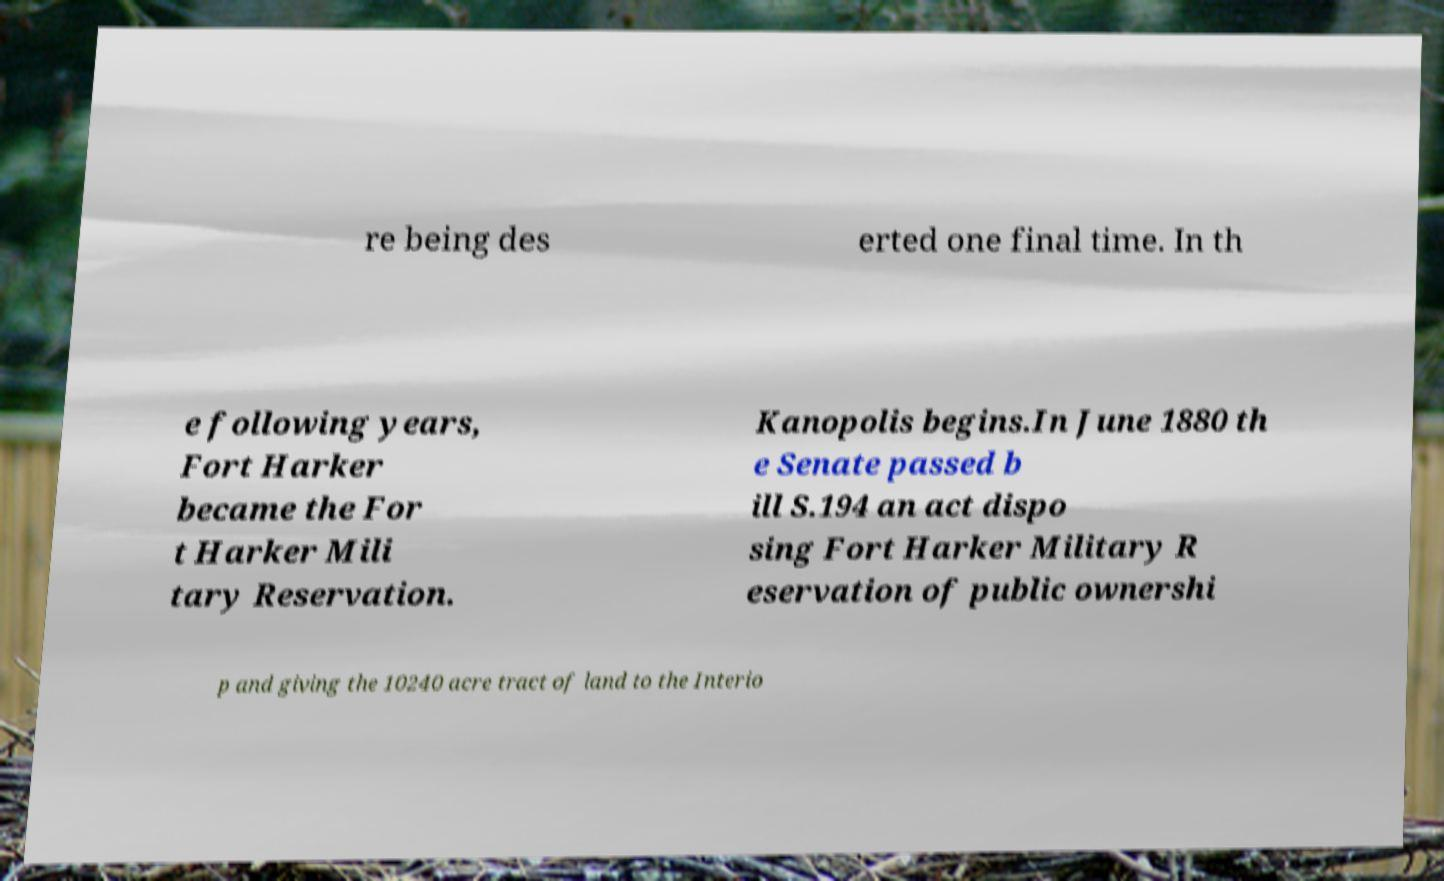What messages or text are displayed in this image? I need them in a readable, typed format. re being des erted one final time. In th e following years, Fort Harker became the For t Harker Mili tary Reservation. Kanopolis begins.In June 1880 th e Senate passed b ill S.194 an act dispo sing Fort Harker Military R eservation of public ownershi p and giving the 10240 acre tract of land to the Interio 